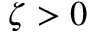<formula> <loc_0><loc_0><loc_500><loc_500>\zeta > 0</formula> 